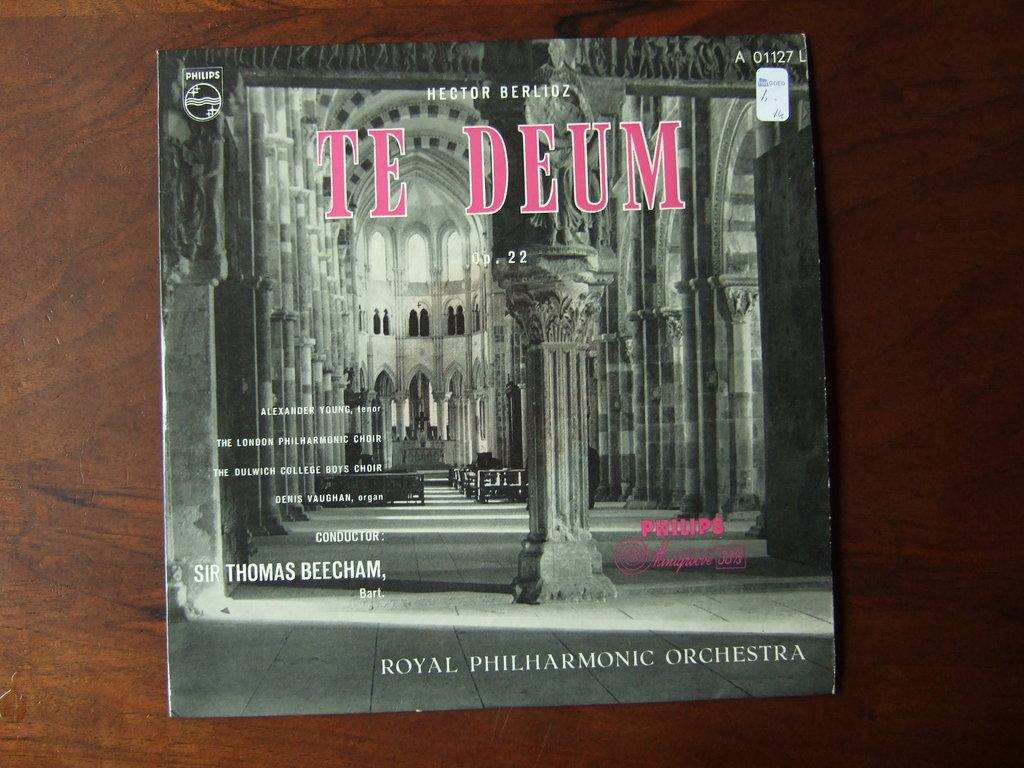<image>
Present a compact description of the photo's key features. An album called Te Deum by the Royal Philharmonic Orchestra 